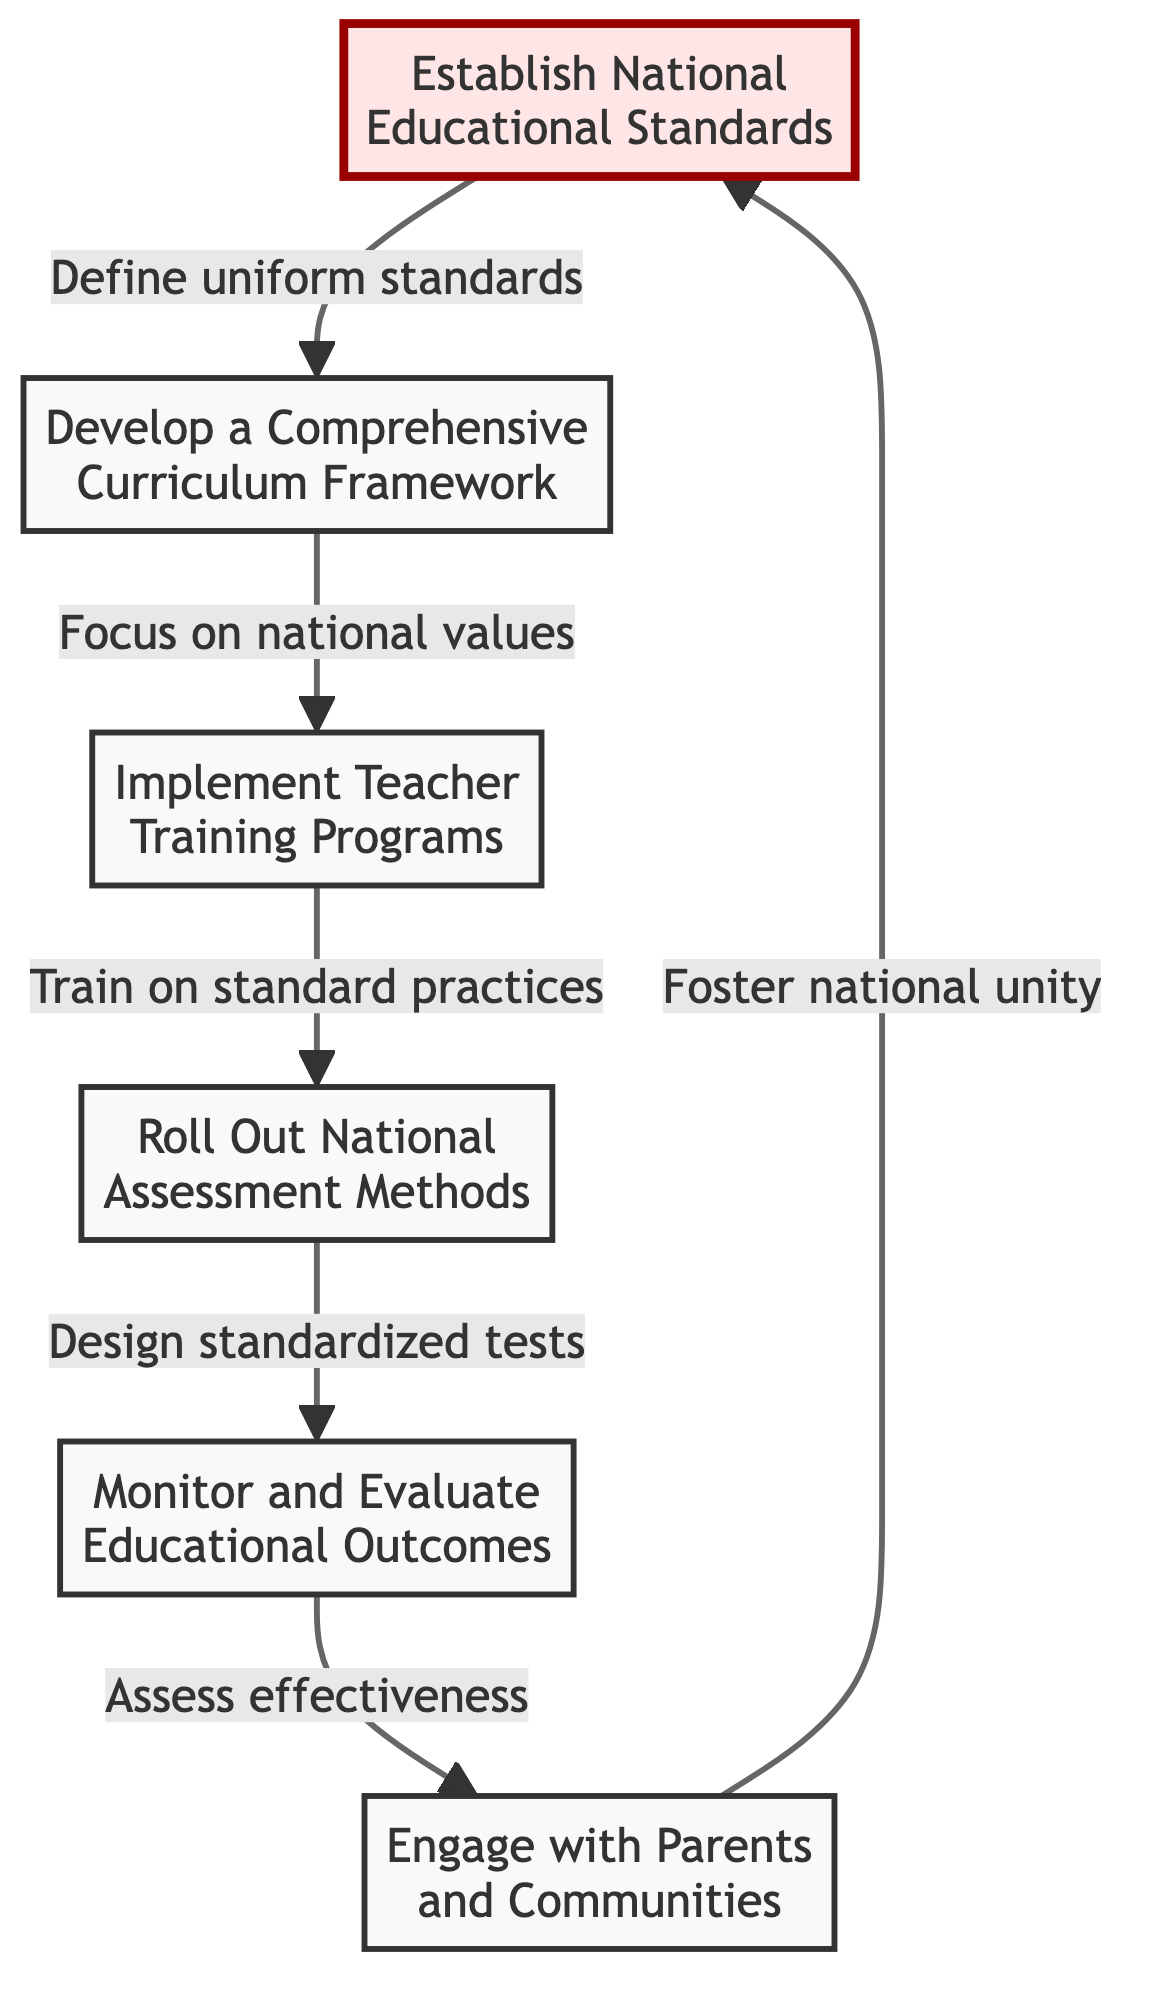What is the first step in the flowchart? The first step in the flowchart is represented by the node labeled "Establish National Educational Standards". It is the starting point of the process and is connected to the second step, indicating that it's the first action to take.
Answer: Establish National Educational Standards How many total steps are there in this diagram? There are a total of six steps in the diagram, each represented by a distinct node. You can count each of the nodes to confirm this amount.
Answer: 6 Which step follows "Implement Teacher Training Programs"? The step that follows "Implement Teacher Training Programs" is "Roll Out National Assessment Methods", as indicated by the directional arrow connecting the two steps in the flowchart.
Answer: Roll Out National Assessment Methods What is the purpose of “Engage with Parents and Communities”? The purpose of "Engage with Parents and Communities" is to "Foster national unity", as mentioned in the description associated with that node, showing its role in the educational process.
Answer: Foster national unity How are the steps connected in the flowchart? The steps are connected through directional arrows that indicate the sequence of actions to be taken, starting from establishing standards and leading to engaging with communities.
Answer: Through directional arrows What is the last step before "Monitor and Evaluate Educational Outcomes"? The last step before "Monitor and Evaluate Educational Outcomes" is "Roll Out National Assessment Methods". This is evident from the flow of the steps in the chart where one leads to the other in a linear fashion.
Answer: Roll Out National Assessment Methods What does the step "Develop a Comprehensive Curriculum Framework" focus on? The focus of "Develop a Comprehensive Curriculum Framework" is to ensure inclusivity for all students and specifically emphasizes national history, culture, and values as part of the curriculum.
Answer: National history, culture, and values What is the common theme among all the steps? The common theme among all the steps is the implementation of a national educational curriculum that adheres to standardized practices and promotes national unity among all students regardless of background.
Answer: National unity and standardization 